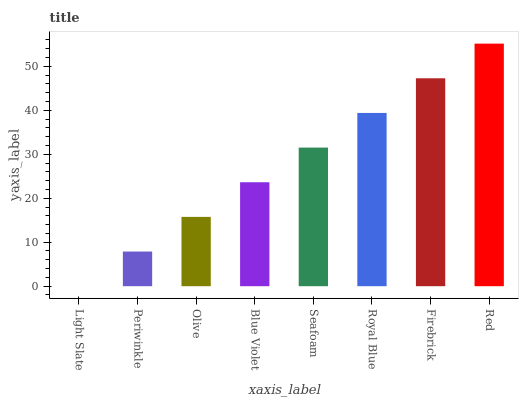Is Light Slate the minimum?
Answer yes or no. Yes. Is Red the maximum?
Answer yes or no. Yes. Is Periwinkle the minimum?
Answer yes or no. No. Is Periwinkle the maximum?
Answer yes or no. No. Is Periwinkle greater than Light Slate?
Answer yes or no. Yes. Is Light Slate less than Periwinkle?
Answer yes or no. Yes. Is Light Slate greater than Periwinkle?
Answer yes or no. No. Is Periwinkle less than Light Slate?
Answer yes or no. No. Is Seafoam the high median?
Answer yes or no. Yes. Is Blue Violet the low median?
Answer yes or no. Yes. Is Firebrick the high median?
Answer yes or no. No. Is Seafoam the low median?
Answer yes or no. No. 